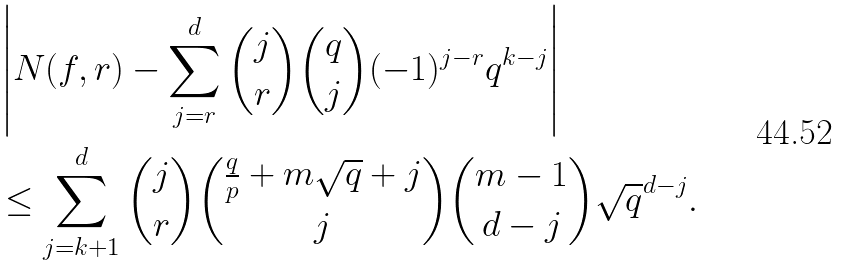Convert formula to latex. <formula><loc_0><loc_0><loc_500><loc_500>& \left | N ( f , r ) - \sum _ { j = r } ^ { d } { j \choose r } { q \choose j } ( - 1 ) ^ { j - r } q ^ { k - j } \right | \\ & \leq \sum _ { j = k + 1 } ^ { d } { j \choose r } { \frac { q } p + m \sqrt { q } + j \choose j } { m - 1 \choose d - j } \sqrt { q } ^ { d - j } .</formula> 